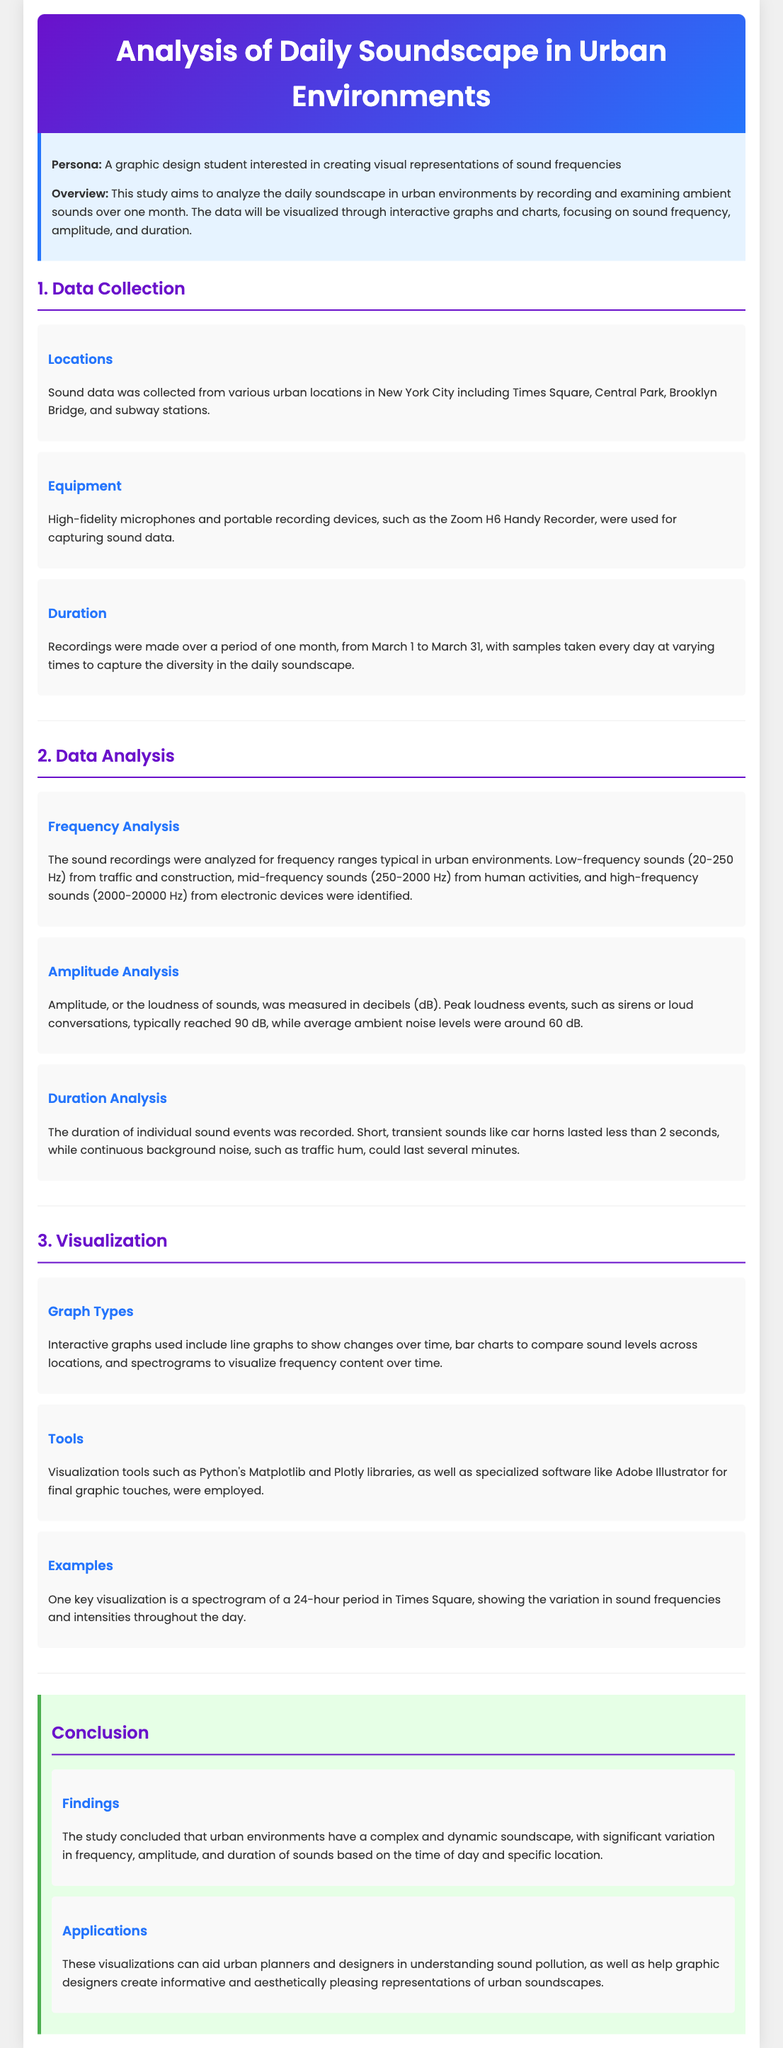What locations were included in the data collection? The locations listed in the document are Times Square, Central Park, Brooklyn Bridge, and subway stations.
Answer: Times Square, Central Park, Brooklyn Bridge, subway stations What equipment was used for recording sound data? The document specifies that high-fidelity microphones and the Zoom H6 Handy Recorder were used.
Answer: High-fidelity microphones, Zoom H6 Handy Recorder How long was the duration of the recordings? The recordings were made over a period of one month from March 1 to March 31.
Answer: One month What is the peak loudness measured in decibels? According to the document, peak loudness events typically reached 90 dB.
Answer: 90 dB What type of graph shows changes over time? The document mentions that line graphs are used to illustrate changes over time.
Answer: Line graphs Which tools were used for visualization? The document lists Python's Matplotlib, Plotly libraries, and Adobe Illustrator as tools used for visualization.
Answer: Python's Matplotlib, Plotly, Adobe Illustrator What was a key visualization example mentioned? The document highlights a spectrogram of a 24-hour period in Times Square as a key visualization.
Answer: Spectrogram of a 24-hour period in Times Square What significant findings were concluded about the urban soundscape? The findings indicate that urban environments have a complex and dynamic soundscape.
Answer: Complex and dynamic soundscape What applications do these visualizations have? The document states that these visualizations can aid urban planners and designers in understanding sound pollution.
Answer: Aid urban planners and designers in understanding sound pollution 